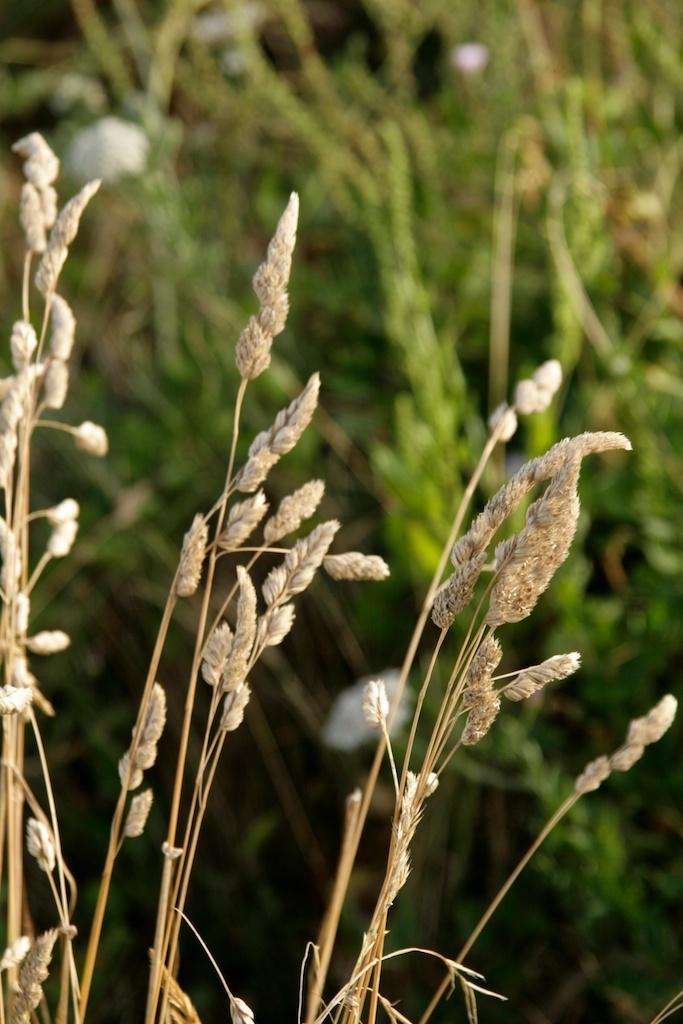What is the main subject in the center of the image? There is grass in the center of the image. Can you describe the color of the grass? The grass is in cream color. What can be seen in the background of the image? There are planets visible in the background of the image, along with a few other objects. Where is the baby sleeping in the image? There is no baby or bed present in the image. What type of ice can be seen melting on the grass in the image? There is no ice present in the image; the grass is in cream color. 